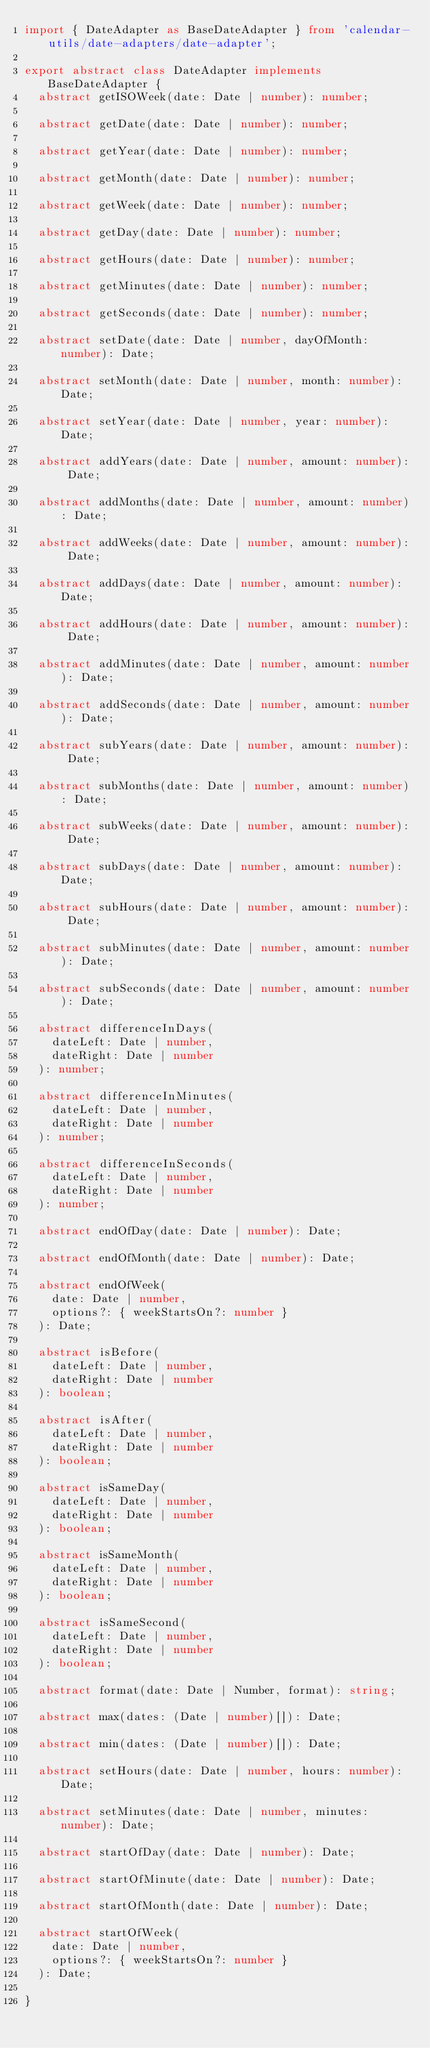<code> <loc_0><loc_0><loc_500><loc_500><_TypeScript_>import { DateAdapter as BaseDateAdapter } from 'calendar-utils/date-adapters/date-adapter';

export abstract class DateAdapter implements BaseDateAdapter {
  abstract getISOWeek(date: Date | number): number;

  abstract getDate(date: Date | number): number;

  abstract getYear(date: Date | number): number;

  abstract getMonth(date: Date | number): number;

  abstract getWeek(date: Date | number): number;

  abstract getDay(date: Date | number): number;

  abstract getHours(date: Date | number): number;

  abstract getMinutes(date: Date | number): number;

  abstract getSeconds(date: Date | number): number;

  abstract setDate(date: Date | number, dayOfMonth: number): Date;

  abstract setMonth(date: Date | number, month: number): Date;

  abstract setYear(date: Date | number, year: number): Date;

  abstract addYears(date: Date | number, amount: number): Date;

  abstract addMonths(date: Date | number, amount: number): Date;

  abstract addWeeks(date: Date | number, amount: number): Date;

  abstract addDays(date: Date | number, amount: number): Date;

  abstract addHours(date: Date | number, amount: number): Date;

  abstract addMinutes(date: Date | number, amount: number): Date;

  abstract addSeconds(date: Date | number, amount: number): Date;

  abstract subYears(date: Date | number, amount: number): Date;

  abstract subMonths(date: Date | number, amount: number): Date;

  abstract subWeeks(date: Date | number, amount: number): Date;

  abstract subDays(date: Date | number, amount: number): Date;

  abstract subHours(date: Date | number, amount: number): Date;

  abstract subMinutes(date: Date | number, amount: number): Date;

  abstract subSeconds(date: Date | number, amount: number): Date;

  abstract differenceInDays(
    dateLeft: Date | number,
    dateRight: Date | number
  ): number;

  abstract differenceInMinutes(
    dateLeft: Date | number,
    dateRight: Date | number
  ): number;

  abstract differenceInSeconds(
    dateLeft: Date | number,
    dateRight: Date | number
  ): number;

  abstract endOfDay(date: Date | number): Date;

  abstract endOfMonth(date: Date | number): Date;

  abstract endOfWeek(
    date: Date | number,
    options?: { weekStartsOn?: number }
  ): Date;

  abstract isBefore(
    dateLeft: Date | number,
    dateRight: Date | number
  ): boolean;

  abstract isAfter(
    dateLeft: Date | number,
    dateRight: Date | number
  ): boolean;

  abstract isSameDay(
    dateLeft: Date | number,
    dateRight: Date | number
  ): boolean;

  abstract isSameMonth(
    dateLeft: Date | number,
    dateRight: Date | number
  ): boolean;

  abstract isSameSecond(
    dateLeft: Date | number,
    dateRight: Date | number
  ): boolean;

  abstract format(date: Date | Number, format): string;

  abstract max(dates: (Date | number)[]): Date;

  abstract min(dates: (Date | number)[]): Date;

  abstract setHours(date: Date | number, hours: number): Date;

  abstract setMinutes(date: Date | number, minutes: number): Date;

  abstract startOfDay(date: Date | number): Date;

  abstract startOfMinute(date: Date | number): Date;

  abstract startOfMonth(date: Date | number): Date;

  abstract startOfWeek(
    date: Date | number,
    options?: { weekStartsOn?: number }
  ): Date;

}
</code> 